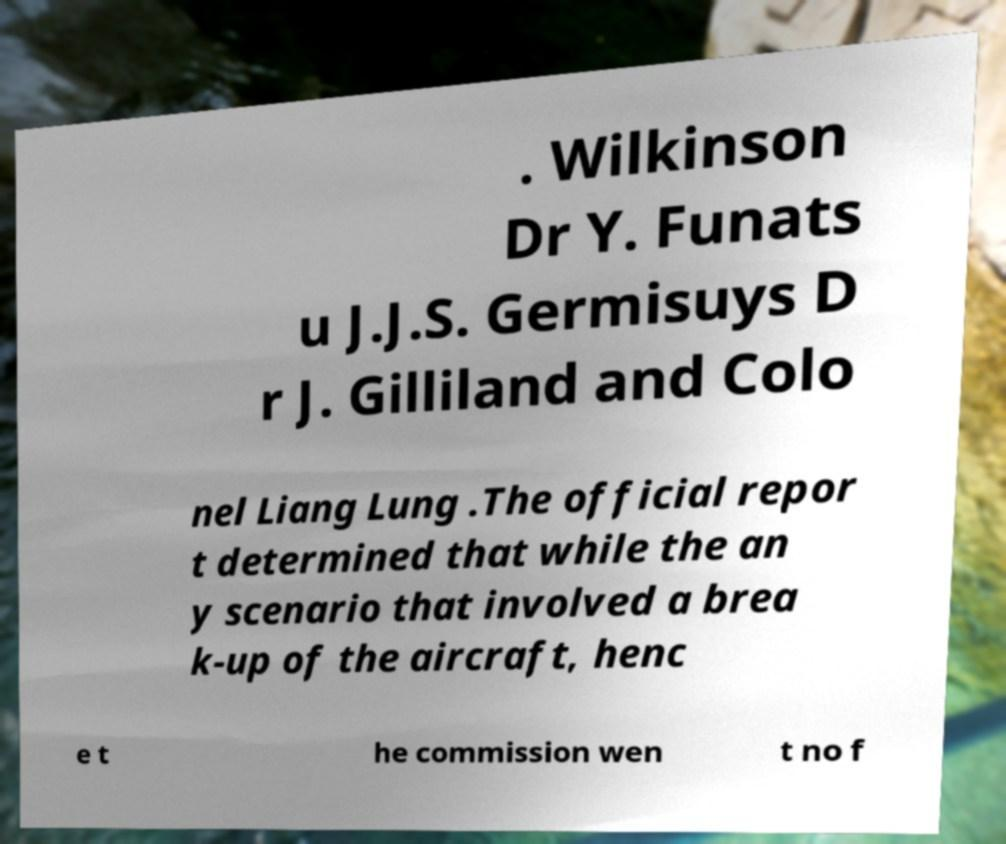For documentation purposes, I need the text within this image transcribed. Could you provide that? . Wilkinson Dr Y. Funats u J.J.S. Germisuys D r J. Gilliland and Colo nel Liang Lung .The official repor t determined that while the an y scenario that involved a brea k-up of the aircraft, henc e t he commission wen t no f 